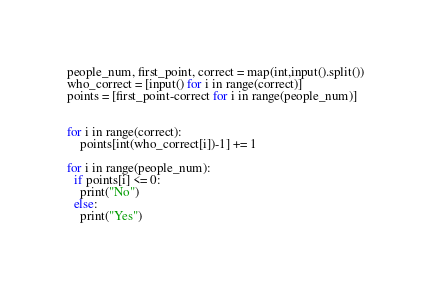Convert code to text. <code><loc_0><loc_0><loc_500><loc_500><_Python_>people_num, first_point, correct = map(int,input().split())
who_correct = [input() for i in range(correct)]
points = [first_point-correct for i in range(people_num)]

 
for i in range(correct):
    points[int(who_correct[i])-1] += 1
    
for i in range(people_num):
  if points[i] <= 0:
  	print("No")
  else:
    print("Yes")
</code> 